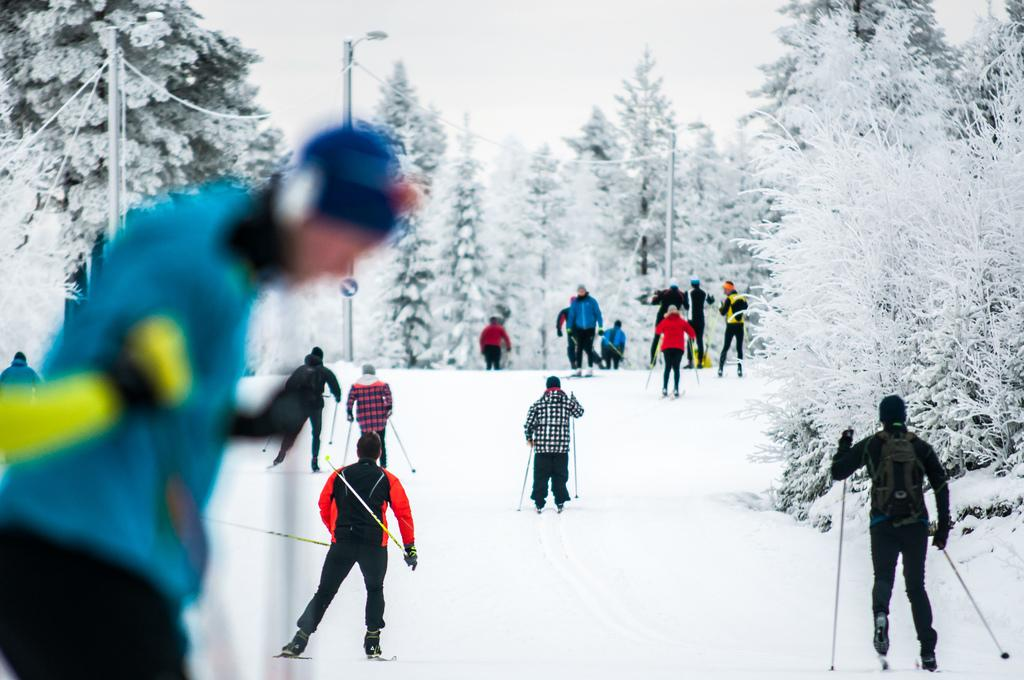What is happening in the image involving the group of people? The people are skating on a snow ground in the image. What can be seen in the background of the image? There are trees and poles in the background of the image. What is visible at the top of the image? The sky is visible at the top of the image. What type of hook is being used to catch fish in the image? There is no hook or fishing activity present in the image. What is the size of the bread being consumed by the people in the image? There is no bread present in the image. 